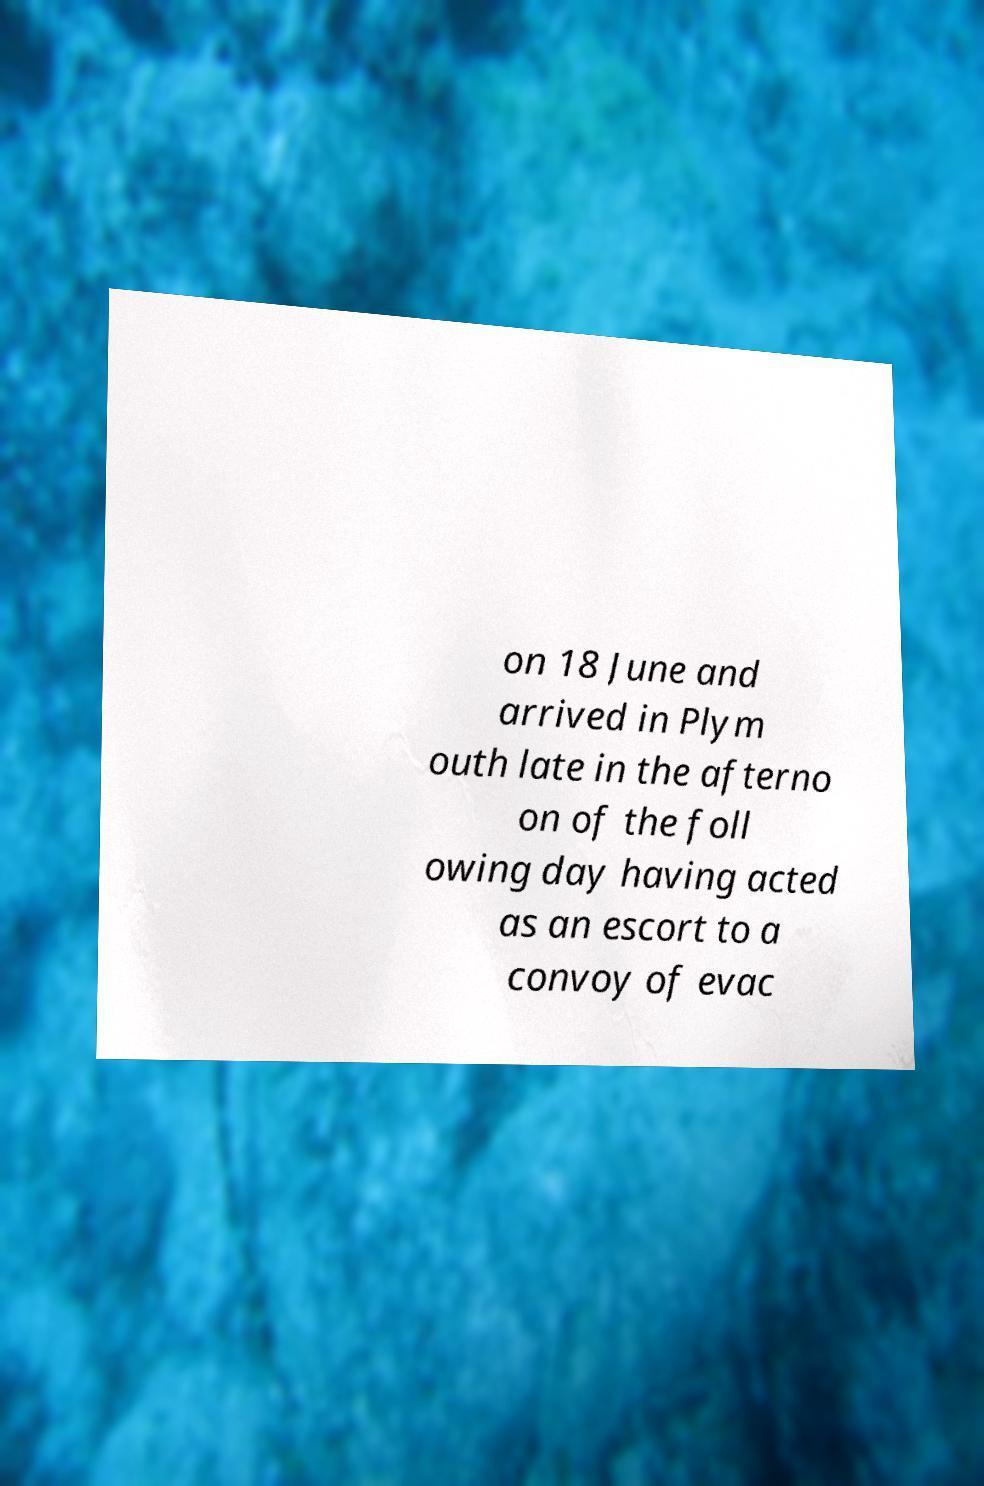Please read and relay the text visible in this image. What does it say? on 18 June and arrived in Plym outh late in the afterno on of the foll owing day having acted as an escort to a convoy of evac 